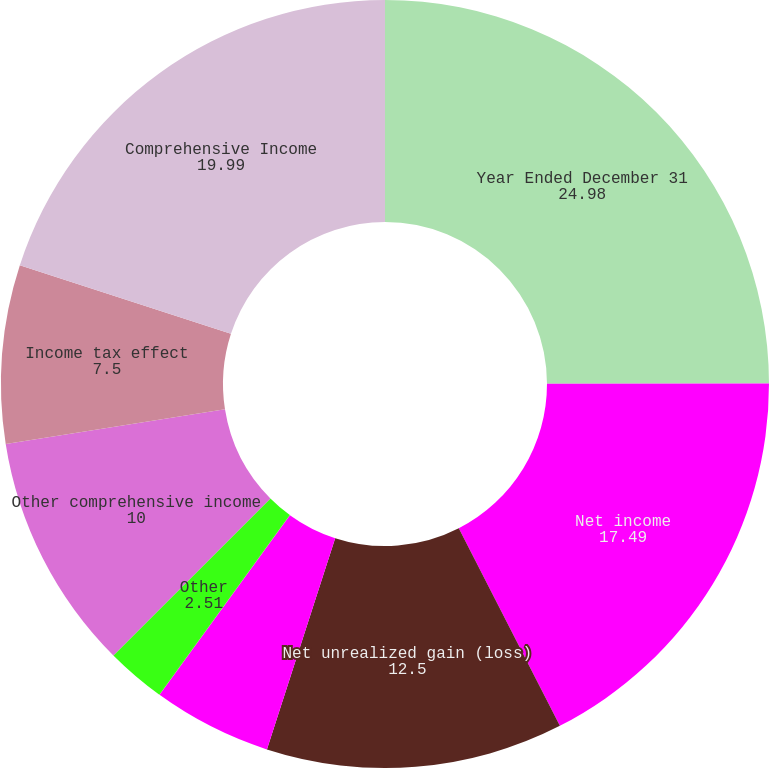<chart> <loc_0><loc_0><loc_500><loc_500><pie_chart><fcel>Year Ended December 31<fcel>Net income<fcel>Net unrealized gain (loss)<fcel>Reclassification of impairment<fcel>Other reclassifications<fcel>Other<fcel>Other comprehensive income<fcel>Income tax effect<fcel>Comprehensive Income<nl><fcel>24.98%<fcel>17.49%<fcel>12.5%<fcel>5.01%<fcel>0.01%<fcel>2.51%<fcel>10.0%<fcel>7.5%<fcel>19.99%<nl></chart> 